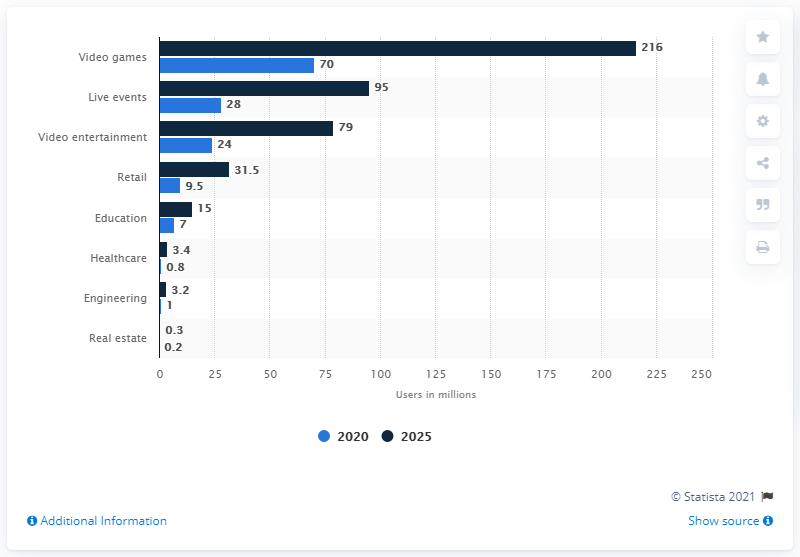Point out several critical features in this image. By 2025, it is projected that augmented and virtual reality software for video games will have approximately 216 million users. 